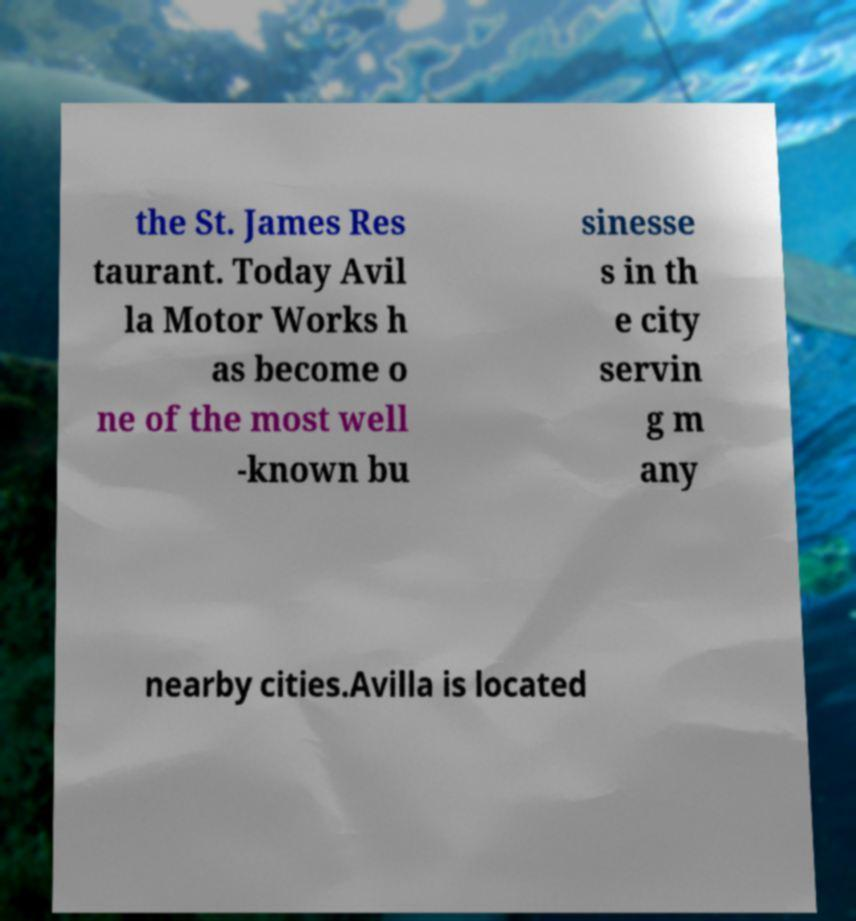There's text embedded in this image that I need extracted. Can you transcribe it verbatim? the St. James Res taurant. Today Avil la Motor Works h as become o ne of the most well -known bu sinesse s in th e city servin g m any nearby cities.Avilla is located 